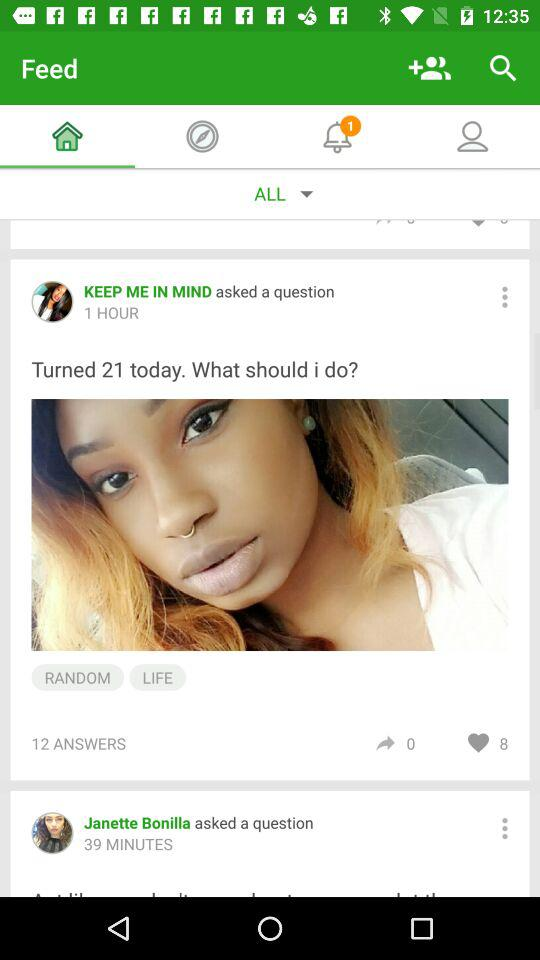How many people have asked questions?
Answer the question using a single word or phrase. 2 